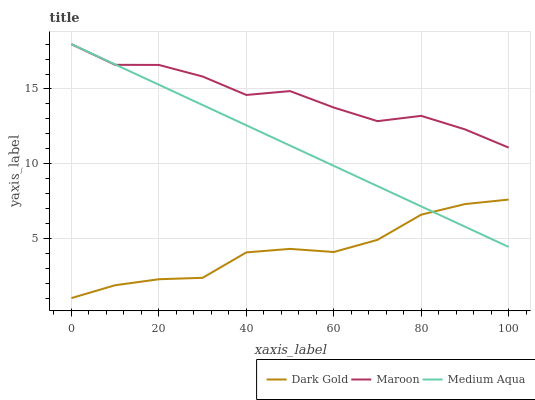Does Dark Gold have the minimum area under the curve?
Answer yes or no. Yes. Does Maroon have the maximum area under the curve?
Answer yes or no. Yes. Does Maroon have the minimum area under the curve?
Answer yes or no. No. Does Dark Gold have the maximum area under the curve?
Answer yes or no. No. Is Medium Aqua the smoothest?
Answer yes or no. Yes. Is Maroon the roughest?
Answer yes or no. Yes. Is Dark Gold the smoothest?
Answer yes or no. No. Is Dark Gold the roughest?
Answer yes or no. No. Does Dark Gold have the lowest value?
Answer yes or no. Yes. Does Maroon have the lowest value?
Answer yes or no. No. Does Maroon have the highest value?
Answer yes or no. Yes. Does Dark Gold have the highest value?
Answer yes or no. No. Is Dark Gold less than Maroon?
Answer yes or no. Yes. Is Maroon greater than Dark Gold?
Answer yes or no. Yes. Does Dark Gold intersect Medium Aqua?
Answer yes or no. Yes. Is Dark Gold less than Medium Aqua?
Answer yes or no. No. Is Dark Gold greater than Medium Aqua?
Answer yes or no. No. Does Dark Gold intersect Maroon?
Answer yes or no. No. 